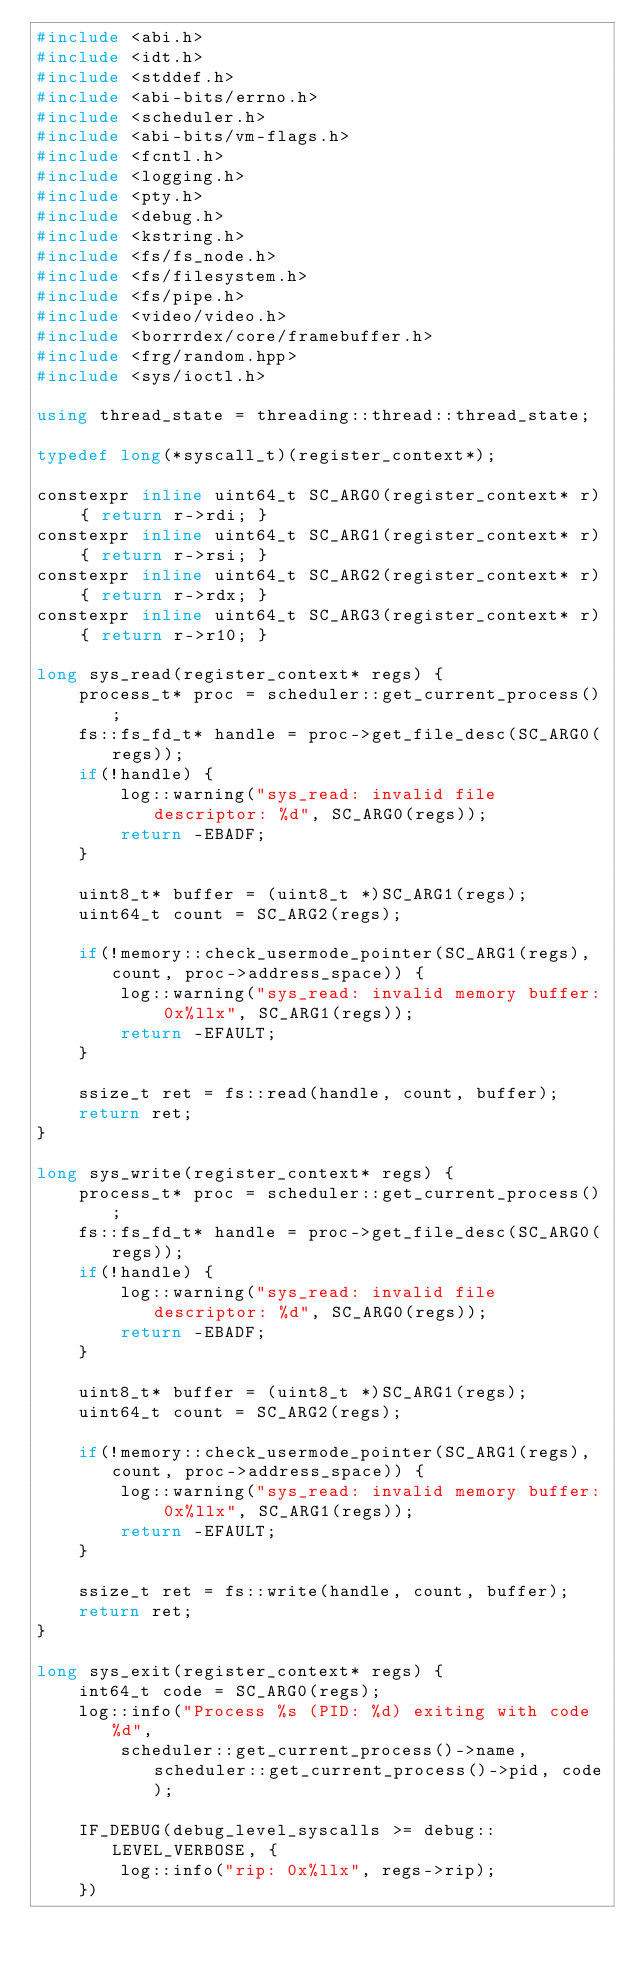<code> <loc_0><loc_0><loc_500><loc_500><_C++_>#include <abi.h>
#include <idt.h>
#include <stddef.h>
#include <abi-bits/errno.h>
#include <scheduler.h>
#include <abi-bits/vm-flags.h>
#include <fcntl.h>
#include <logging.h>
#include <pty.h>
#include <debug.h>
#include <kstring.h>
#include <fs/fs_node.h>
#include <fs/filesystem.h>
#include <fs/pipe.h>
#include <video/video.h>
#include <borrrdex/core/framebuffer.h>
#include <frg/random.hpp>
#include <sys/ioctl.h>

using thread_state = threading::thread::thread_state;

typedef long(*syscall_t)(register_context*);

constexpr inline uint64_t SC_ARG0(register_context* r) { return r->rdi; }
constexpr inline uint64_t SC_ARG1(register_context* r) { return r->rsi; }
constexpr inline uint64_t SC_ARG2(register_context* r) { return r->rdx; }
constexpr inline uint64_t SC_ARG3(register_context* r) { return r->r10; }

long sys_read(register_context* regs) {
    process_t* proc = scheduler::get_current_process();
    fs::fs_fd_t* handle = proc->get_file_desc(SC_ARG0(regs));
    if(!handle) {
        log::warning("sys_read: invalid file descriptor: %d", SC_ARG0(regs));
        return -EBADF;
    }

    uint8_t* buffer = (uint8_t *)SC_ARG1(regs);
    uint64_t count = SC_ARG2(regs);

    if(!memory::check_usermode_pointer(SC_ARG1(regs), count, proc->address_space)) {
        log::warning("sys_read: invalid memory buffer: 0x%llx", SC_ARG1(regs));
        return -EFAULT;
    }

    ssize_t ret = fs::read(handle, count, buffer);
    return ret;
}

long sys_write(register_context* regs) {
    process_t* proc = scheduler::get_current_process();
    fs::fs_fd_t* handle = proc->get_file_desc(SC_ARG0(regs));
    if(!handle) {
        log::warning("sys_read: invalid file descriptor: %d", SC_ARG0(regs));
        return -EBADF;
    }

    uint8_t* buffer = (uint8_t *)SC_ARG1(regs);
    uint64_t count = SC_ARG2(regs);

    if(!memory::check_usermode_pointer(SC_ARG1(regs), count, proc->address_space)) {
        log::warning("sys_read: invalid memory buffer: 0x%llx", SC_ARG1(regs));
        return -EFAULT;
    }

    ssize_t ret = fs::write(handle, count, buffer);
    return ret;
}

long sys_exit(register_context* regs) {
    int64_t code = SC_ARG0(regs);
    log::info("Process %s (PID: %d) exiting with code %d", 
        scheduler::get_current_process()->name, scheduler::get_current_process()->pid, code);

    IF_DEBUG(debug_level_syscalls >= debug::LEVEL_VERBOSE, {
        log::info("rip: 0x%llx", regs->rip);
    })
</code> 